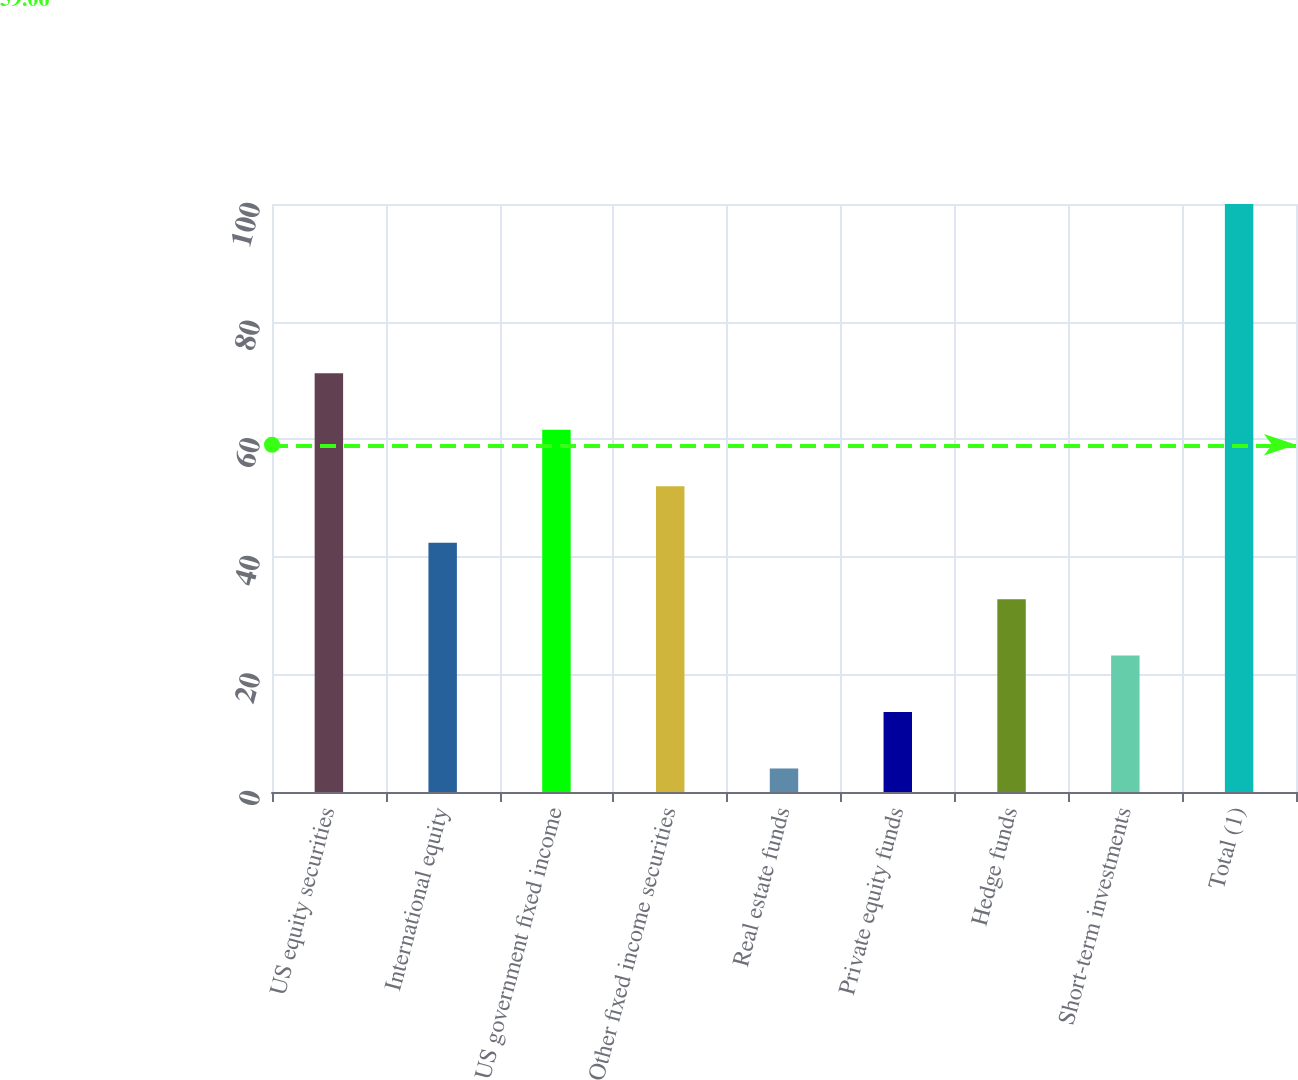<chart> <loc_0><loc_0><loc_500><loc_500><bar_chart><fcel>US equity securities<fcel>International equity<fcel>US government fixed income<fcel>Other fixed income securities<fcel>Real estate funds<fcel>Private equity funds<fcel>Hedge funds<fcel>Short-term investments<fcel>Total (1)<nl><fcel>71.2<fcel>42.4<fcel>61.6<fcel>52<fcel>4<fcel>13.6<fcel>32.8<fcel>23.2<fcel>100<nl></chart> 